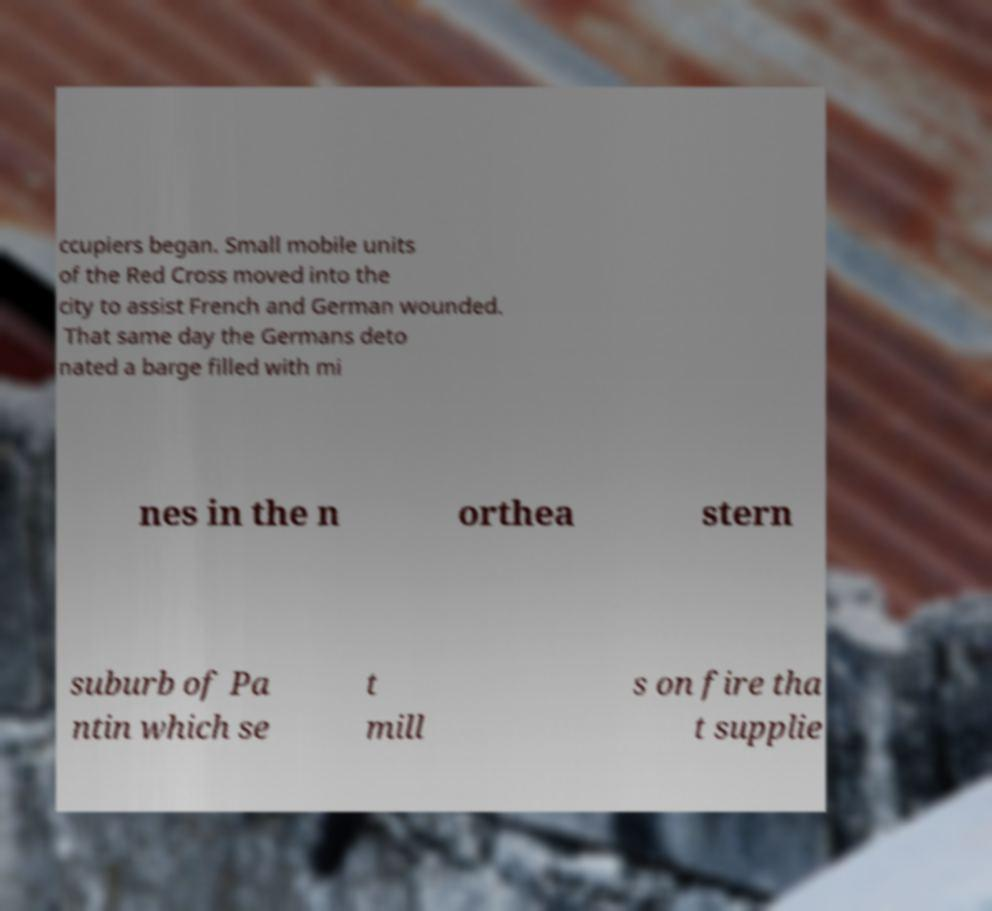Please read and relay the text visible in this image. What does it say? ccupiers began. Small mobile units of the Red Cross moved into the city to assist French and German wounded. That same day the Germans deto nated a barge filled with mi nes in the n orthea stern suburb of Pa ntin which se t mill s on fire tha t supplie 